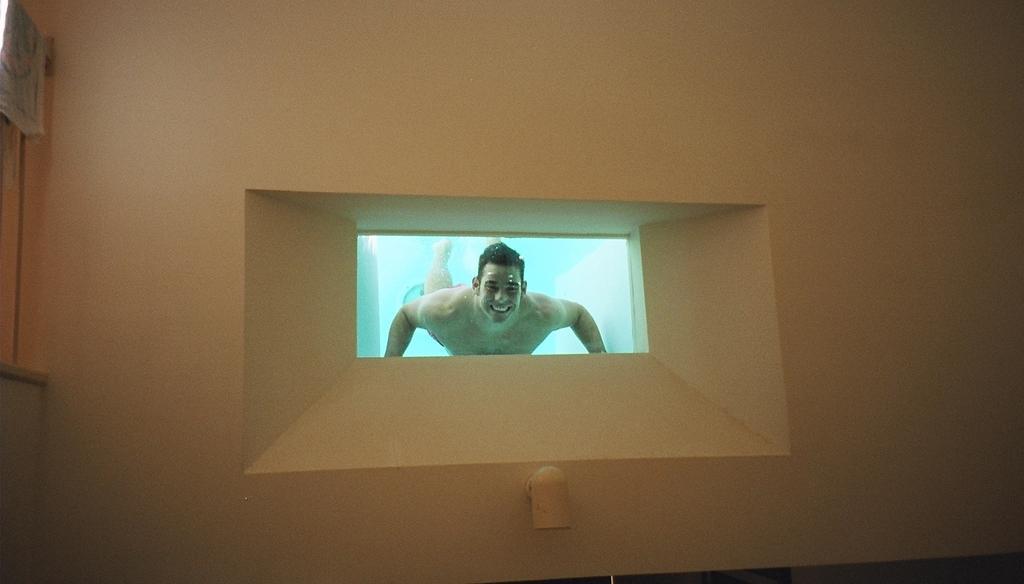How would you summarize this image in a sentence or two? In this picture I can see there is a man swimming in the water and laughing. He is visible from the window, which is on the wall. 